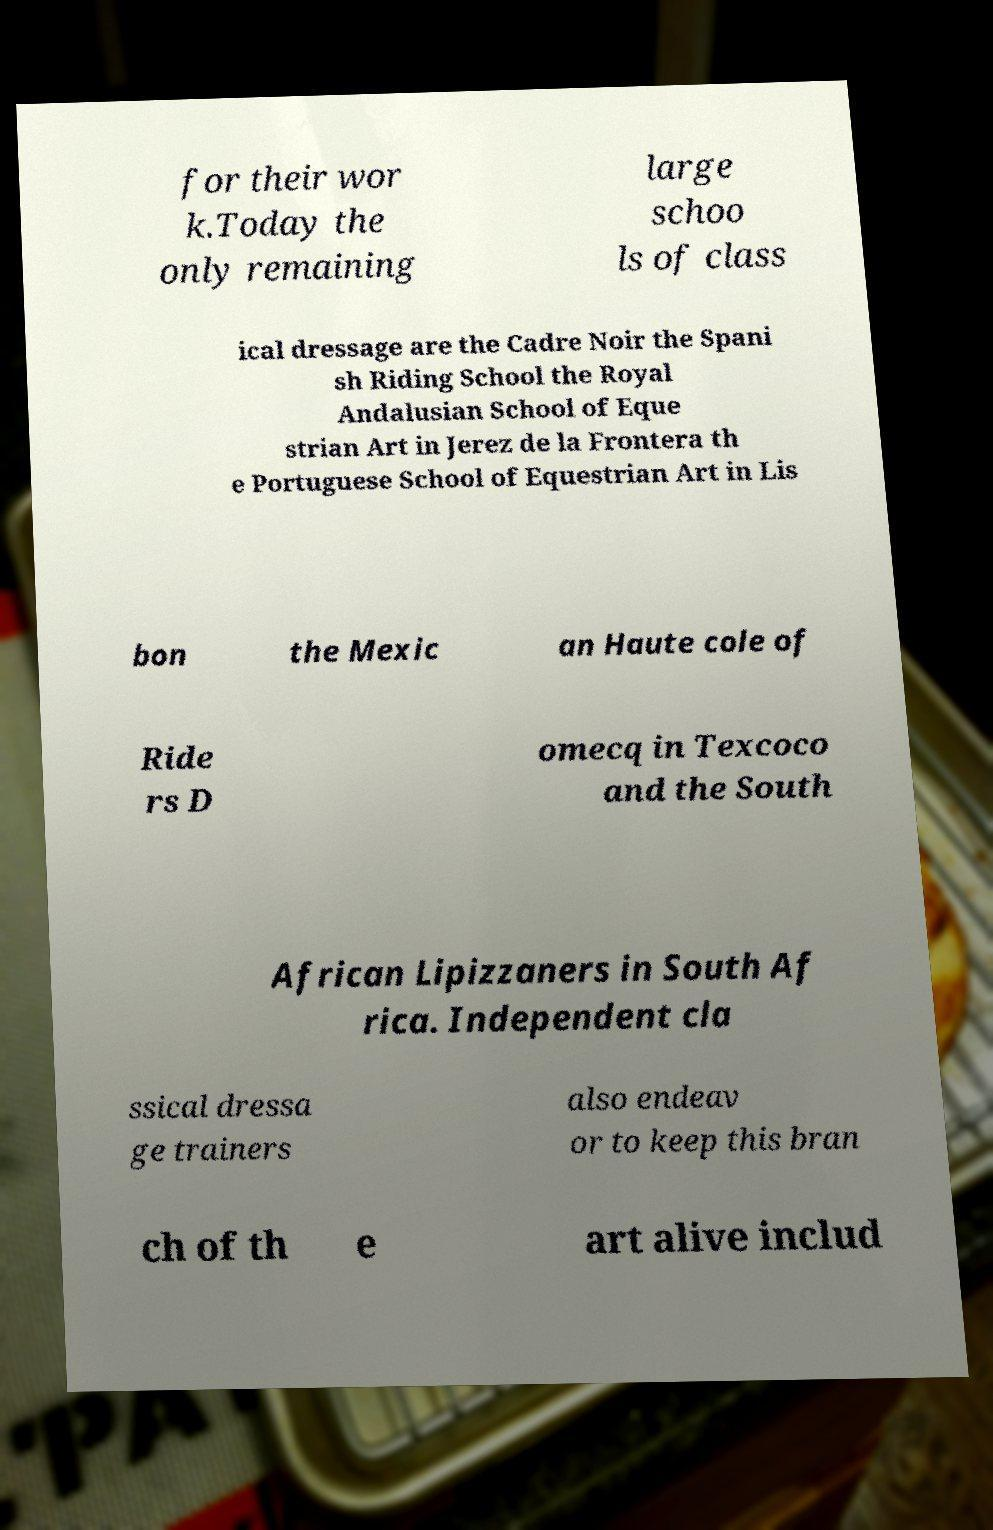For documentation purposes, I need the text within this image transcribed. Could you provide that? for their wor k.Today the only remaining large schoo ls of class ical dressage are the Cadre Noir the Spani sh Riding School the Royal Andalusian School of Eque strian Art in Jerez de la Frontera th e Portuguese School of Equestrian Art in Lis bon the Mexic an Haute cole of Ride rs D omecq in Texcoco and the South African Lipizzaners in South Af rica. Independent cla ssical dressa ge trainers also endeav or to keep this bran ch of th e art alive includ 